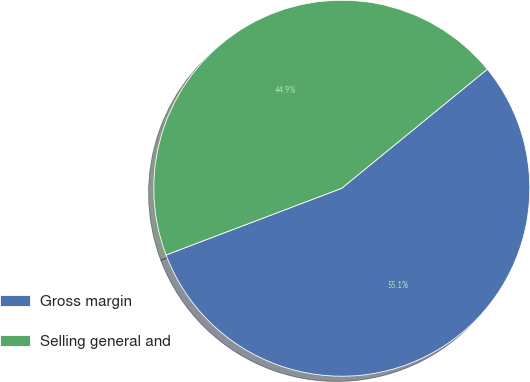Convert chart to OTSL. <chart><loc_0><loc_0><loc_500><loc_500><pie_chart><fcel>Gross margin<fcel>Selling general and<nl><fcel>55.13%<fcel>44.87%<nl></chart> 